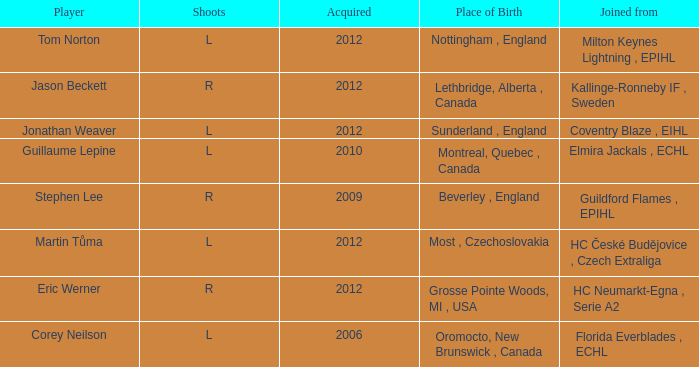Who acquired tom norton? 2012.0. 